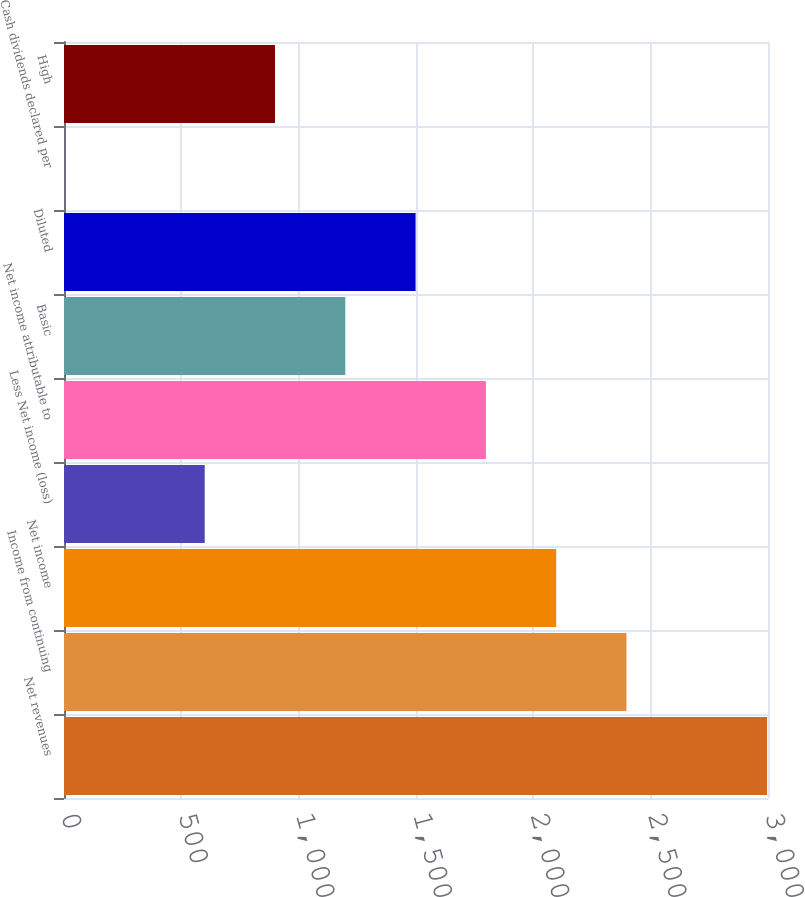Convert chart. <chart><loc_0><loc_0><loc_500><loc_500><bar_chart><fcel>Net revenues<fcel>Income from continuing<fcel>Net income<fcel>Less Net income (loss)<fcel>Net income attributable to<fcel>Basic<fcel>Diluted<fcel>Cash dividends declared per<fcel>High<nl><fcel>2996.02<fcel>2396.92<fcel>2097.37<fcel>599.62<fcel>1797.82<fcel>1198.72<fcel>1498.27<fcel>0.52<fcel>899.17<nl></chart> 